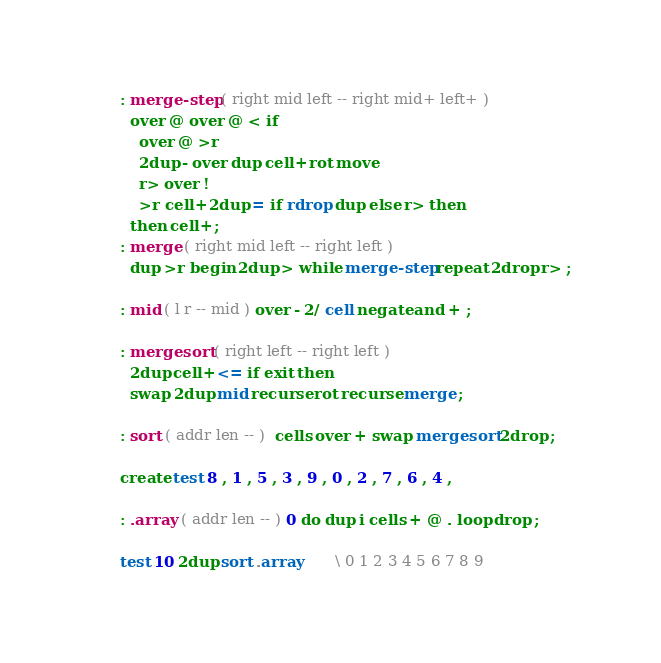<code> <loc_0><loc_0><loc_500><loc_500><_Forth_>: merge-step ( right mid left -- right mid+ left+ )
  over @ over @ < if
    over @ >r
    2dup - over dup cell+ rot move
    r> over !
    >r cell+ 2dup = if rdrop dup else r> then
  then cell+ ;
: merge ( right mid left -- right left )
  dup >r begin 2dup > while merge-step repeat 2drop r> ;

: mid ( l r -- mid ) over - 2/ cell negate and + ;

: mergesort ( right left -- right left )
  2dup cell+ <= if exit then
  swap 2dup mid recurse rot recurse merge ;

: sort ( addr len -- )  cells over + swap mergesort 2drop ;

create test 8 , 1 , 5 , 3 , 9 , 0 , 2 , 7 , 6 , 4 ,

: .array ( addr len -- ) 0 do dup i cells + @ . loop drop ;

test 10 2dup sort .array       \ 0 1 2 3 4 5 6 7 8 9
</code> 